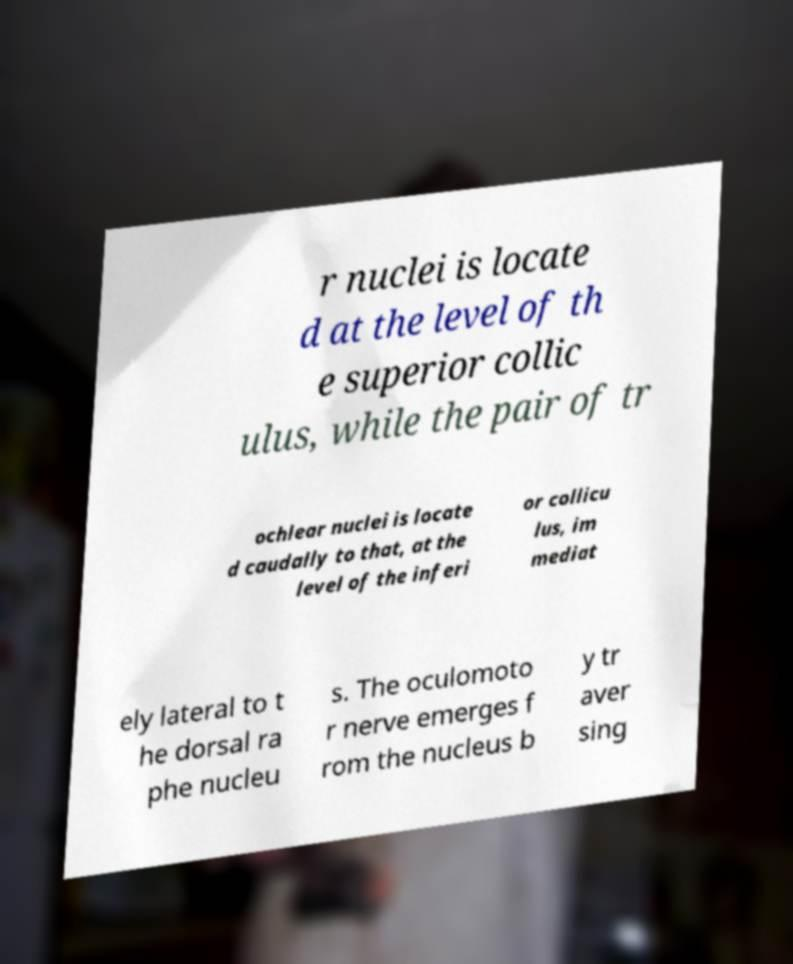For documentation purposes, I need the text within this image transcribed. Could you provide that? r nuclei is locate d at the level of th e superior collic ulus, while the pair of tr ochlear nuclei is locate d caudally to that, at the level of the inferi or collicu lus, im mediat ely lateral to t he dorsal ra phe nucleu s. The oculomoto r nerve emerges f rom the nucleus b y tr aver sing 